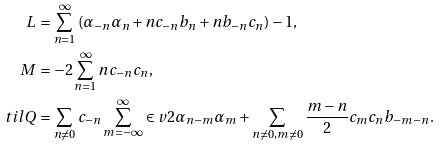Convert formula to latex. <formula><loc_0><loc_0><loc_500><loc_500>L \, & = \sum _ { n = 1 } ^ { \infty } \left ( \alpha _ { - n } \alpha _ { n } + n c _ { - n } b _ { n } + n b _ { - n } c _ { n } \right ) - 1 , \\ M \, & = - 2 \sum _ { n = 1 } ^ { \infty } n c _ { - n } c _ { n } , \\ \ t i l Q & = \sum _ { n \neq 0 } c _ { - n } \sum _ { m = - \infty } ^ { \infty } \in v { 2 } \alpha _ { n - m } \alpha _ { m } + \sum _ { n \neq 0 , m \neq 0 } \frac { m - n } { 2 } c _ { m } c _ { n } b _ { - m - n } .</formula> 